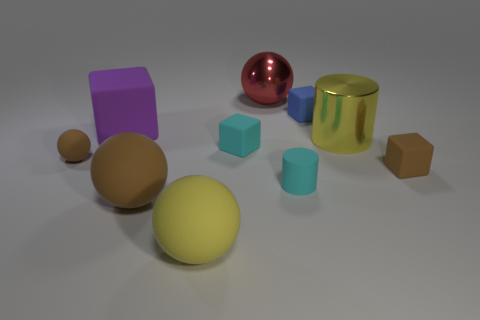Which object in the image looks the most reflective? The most reflective object is the red sphere. Its polished, mirror-like finish stands out against the matte surfaces of the other items, making it capture and reflect the environment with high clarity. 